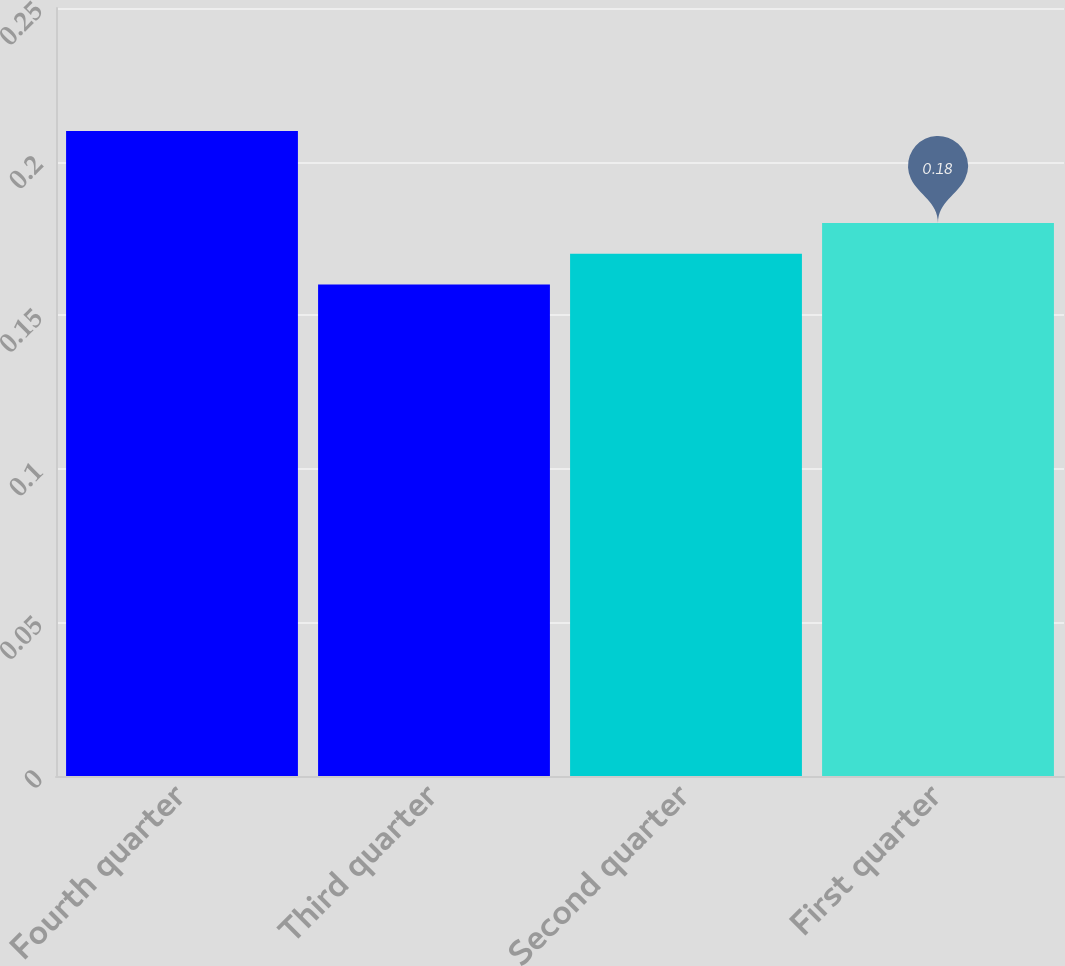Convert chart to OTSL. <chart><loc_0><loc_0><loc_500><loc_500><bar_chart><fcel>Fourth quarter<fcel>Third quarter<fcel>Second quarter<fcel>First quarter<nl><fcel>0.21<fcel>0.16<fcel>0.17<fcel>0.18<nl></chart> 